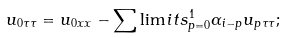<formula> <loc_0><loc_0><loc_500><loc_500>u _ { 0 \tau \tau } = u _ { 0 x x } - \sum \lim i t s _ { p = 0 } ^ { 1 } \alpha _ { i - p } u _ { p \tau \tau } ;</formula> 